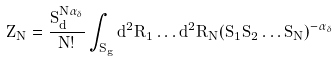Convert formula to latex. <formula><loc_0><loc_0><loc_500><loc_500>Z _ { N } = \frac { S _ { d } ^ { N \alpha _ { \delta } } } { N ! } \int _ { S _ { g } } d ^ { 2 } \vec { R } _ { 1 } \dots d ^ { 2 } \vec { R } _ { N } ( \bar { S } _ { 1 } \bar { S } _ { 2 } \dots \bar { S } _ { N } ) ^ { - \alpha _ { \delta } }</formula> 